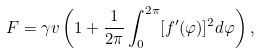Convert formula to latex. <formula><loc_0><loc_0><loc_500><loc_500>F = \gamma v \left ( 1 + \frac { 1 } { 2 \pi } \int _ { 0 } ^ { 2 \pi } [ f ^ { \prime } ( \varphi ) ] ^ { 2 } d \varphi \right ) ,</formula> 